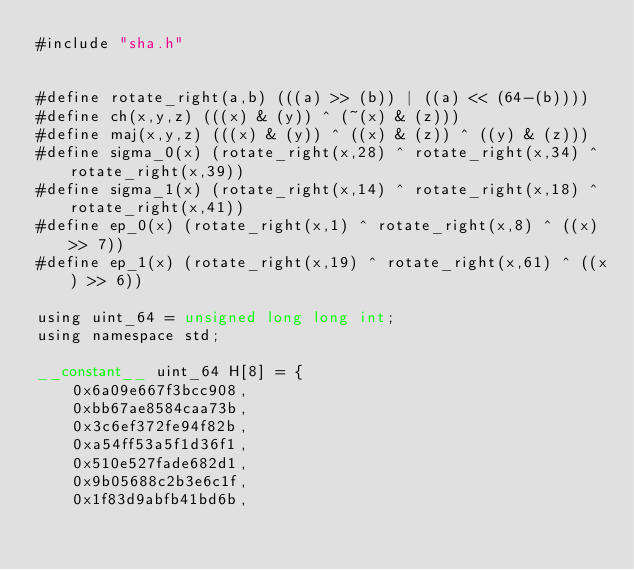<code> <loc_0><loc_0><loc_500><loc_500><_Cuda_>#include "sha.h"


#define rotate_right(a,b) (((a) >> (b)) | ((a) << (64-(b))))
#define ch(x,y,z) (((x) & (y)) ^ (~(x) & (z)))
#define maj(x,y,z) (((x) & (y)) ^ ((x) & (z)) ^ ((y) & (z)))
#define sigma_0(x) (rotate_right(x,28) ^ rotate_right(x,34) ^ rotate_right(x,39))
#define sigma_1(x) (rotate_right(x,14) ^ rotate_right(x,18) ^ rotate_right(x,41))
#define ep_0(x) (rotate_right(x,1) ^ rotate_right(x,8) ^ ((x) >> 7))
#define ep_1(x) (rotate_right(x,19) ^ rotate_right(x,61) ^ ((x) >> 6))

using uint_64 = unsigned long long int;
using namespace std;

__constant__ uint_64 H[8] = {
    0x6a09e667f3bcc908,
    0xbb67ae8584caa73b,
    0x3c6ef372fe94f82b,
    0xa54ff53a5f1d36f1,
    0x510e527fade682d1,
    0x9b05688c2b3e6c1f,
    0x1f83d9abfb41bd6b,</code> 